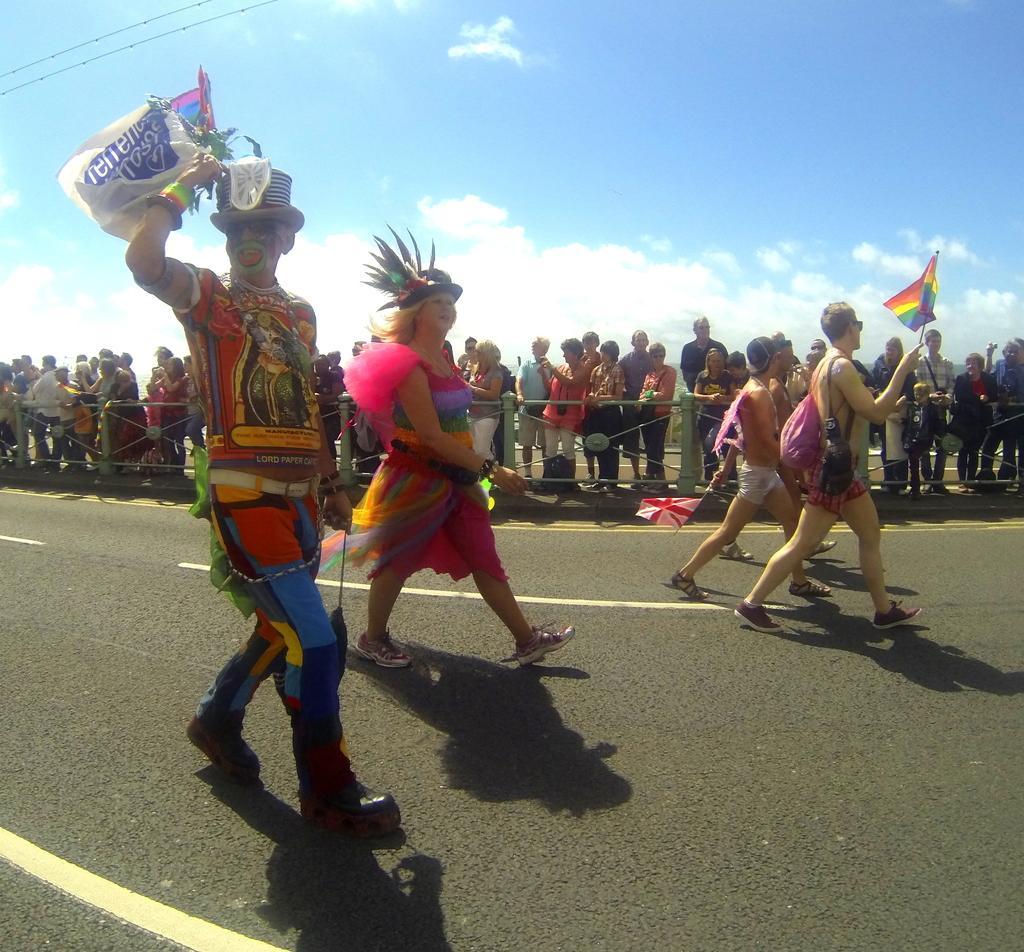Please provide a concise description of this image. In this image I can see road and on it I can see white lines, shadows and I can see few people are standing. I can see few of them are wearing caps, few of them are carrying bags and here I can see he is holding a flag. In the background I can see number of people are standing and I can see clouds and the sky. 